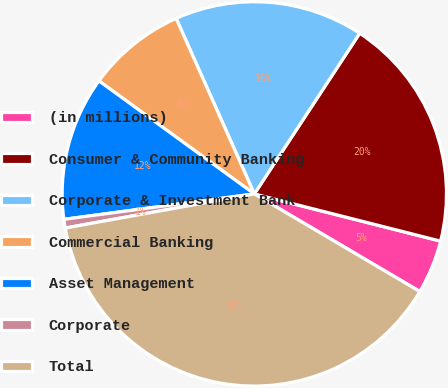<chart> <loc_0><loc_0><loc_500><loc_500><pie_chart><fcel>(in millions)<fcel>Consumer & Community Banking<fcel>Corporate & Investment Bank<fcel>Commercial Banking<fcel>Asset Management<fcel>Corporate<fcel>Total<nl><fcel>4.53%<fcel>19.71%<fcel>15.91%<fcel>8.32%<fcel>12.12%<fcel>0.73%<fcel>38.68%<nl></chart> 